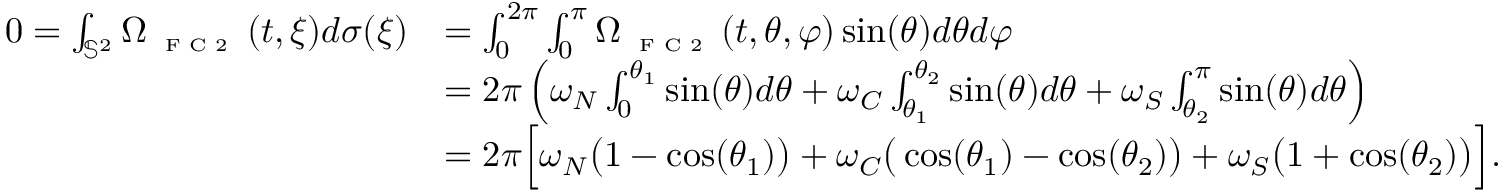Convert formula to latex. <formula><loc_0><loc_0><loc_500><loc_500>\begin{array} { r l } { 0 = \int _ { \mathbb { S } ^ { 2 } } \Omega _ { F C 2 } ( t , \xi ) d \sigma ( \xi ) } & { = \int _ { 0 } ^ { 2 \pi } \int _ { 0 } ^ { \pi } \Omega _ { F C 2 } ( t , \theta , \varphi ) \sin ( \theta ) d \theta d \varphi } \\ & { = 2 \pi \left ( \omega _ { N } \int _ { 0 } ^ { \theta _ { 1 } } \sin ( \theta ) d \theta + \omega _ { C } \int _ { \theta _ { 1 } } ^ { \theta _ { 2 } } \sin ( \theta ) d \theta + \omega _ { S } \int _ { \theta _ { 2 } } ^ { \pi } \sin ( \theta ) d \theta \right ) } \\ & { = 2 \pi \left [ \omega _ { N } \left ( 1 - \cos ( \theta _ { 1 } ) \right ) + \omega _ { C } \left ( \cos ( \theta _ { 1 } ) - \cos ( \theta _ { 2 } ) \right ) + \omega _ { S } \left ( 1 + \cos ( \theta _ { 2 } ) \right ) \right ] . } \end{array}</formula> 